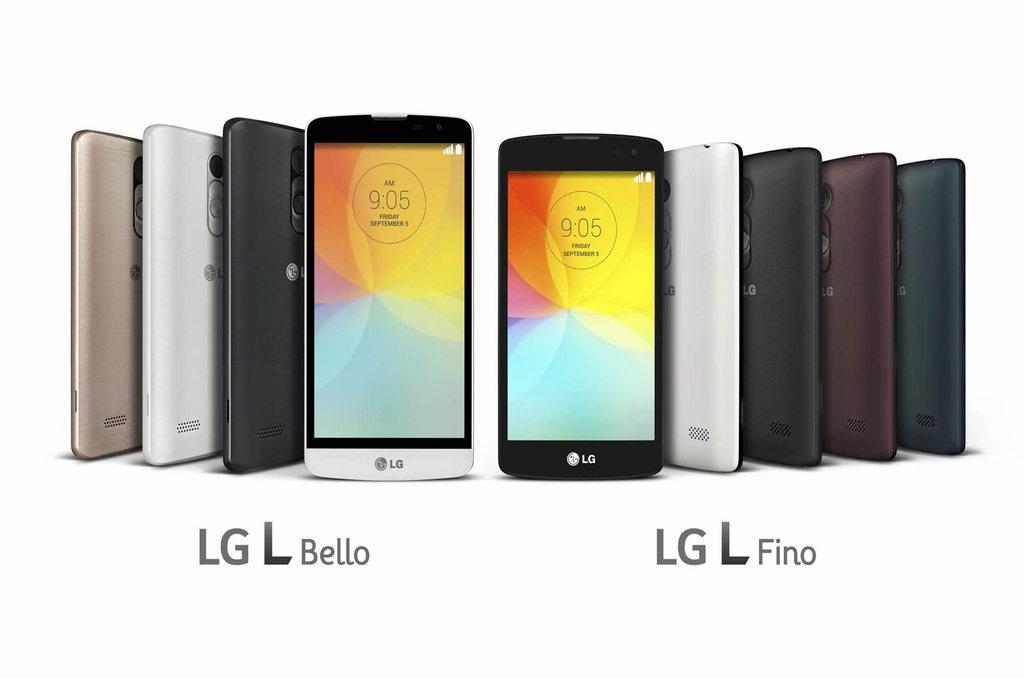<image>
Create a compact narrative representing the image presented. LG L Bello phones on the left and LG L Fino phones on the right are standing upright against a white background 